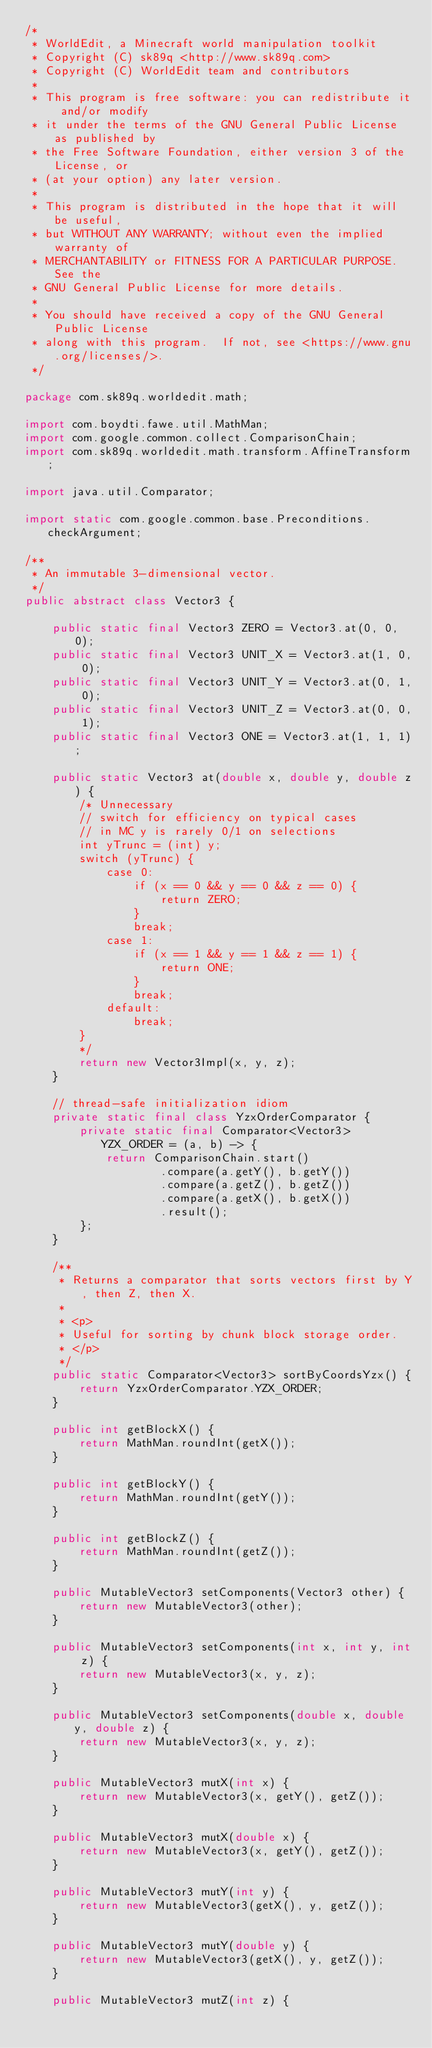<code> <loc_0><loc_0><loc_500><loc_500><_Java_>/*
 * WorldEdit, a Minecraft world manipulation toolkit
 * Copyright (C) sk89q <http://www.sk89q.com>
 * Copyright (C) WorldEdit team and contributors
 *
 * This program is free software: you can redistribute it and/or modify
 * it under the terms of the GNU General Public License as published by
 * the Free Software Foundation, either version 3 of the License, or
 * (at your option) any later version.
 *
 * This program is distributed in the hope that it will be useful,
 * but WITHOUT ANY WARRANTY; without even the implied warranty of
 * MERCHANTABILITY or FITNESS FOR A PARTICULAR PURPOSE.  See the
 * GNU General Public License for more details.
 *
 * You should have received a copy of the GNU General Public License
 * along with this program.  If not, see <https://www.gnu.org/licenses/>.
 */

package com.sk89q.worldedit.math;

import com.boydti.fawe.util.MathMan;
import com.google.common.collect.ComparisonChain;
import com.sk89q.worldedit.math.transform.AffineTransform;

import java.util.Comparator;

import static com.google.common.base.Preconditions.checkArgument;

/**
 * An immutable 3-dimensional vector.
 */
public abstract class Vector3 {

    public static final Vector3 ZERO = Vector3.at(0, 0, 0);
    public static final Vector3 UNIT_X = Vector3.at(1, 0, 0);
    public static final Vector3 UNIT_Y = Vector3.at(0, 1, 0);
    public static final Vector3 UNIT_Z = Vector3.at(0, 0, 1);
    public static final Vector3 ONE = Vector3.at(1, 1, 1);

    public static Vector3 at(double x, double y, double z) {
        /* Unnecessary
        // switch for efficiency on typical cases
        // in MC y is rarely 0/1 on selections
        int yTrunc = (int) y;
        switch (yTrunc) {
            case 0:
                if (x == 0 && y == 0 && z == 0) {
                    return ZERO;
                }
                break;
            case 1:
                if (x == 1 && y == 1 && z == 1) {
                    return ONE;
                }
                break;
            default:
                break;
        }
        */
        return new Vector3Impl(x, y, z);
    }

    // thread-safe initialization idiom
    private static final class YzxOrderComparator {
        private static final Comparator<Vector3> YZX_ORDER = (a, b) -> {
            return ComparisonChain.start()
                    .compare(a.getY(), b.getY())
                    .compare(a.getZ(), b.getZ())
                    .compare(a.getX(), b.getX())
                    .result();
        };
    }

    /**
     * Returns a comparator that sorts vectors first by Y, then Z, then X.
     *
     * <p>
     * Useful for sorting by chunk block storage order.
     * </p>
     */
    public static Comparator<Vector3> sortByCoordsYzx() {
        return YzxOrderComparator.YZX_ORDER;
    }

    public int getBlockX() {
        return MathMan.roundInt(getX());
    }

    public int getBlockY() {
        return MathMan.roundInt(getY());
    }

    public int getBlockZ() {
        return MathMan.roundInt(getZ());
    }

    public MutableVector3 setComponents(Vector3 other) {
        return new MutableVector3(other);
    }

    public MutableVector3 setComponents(int x, int y, int z) {
        return new MutableVector3(x, y, z);
    }

    public MutableVector3 setComponents(double x, double y, double z) {
        return new MutableVector3(x, y, z);
    }

    public MutableVector3 mutX(int x) {
        return new MutableVector3(x, getY(), getZ());
    }

    public MutableVector3 mutX(double x) {
        return new MutableVector3(x, getY(), getZ());
    }

    public MutableVector3 mutY(int y) {
        return new MutableVector3(getX(), y, getZ());
    }

    public MutableVector3 mutY(double y) {
        return new MutableVector3(getX(), y, getZ());
    }

    public MutableVector3 mutZ(int z) {</code> 